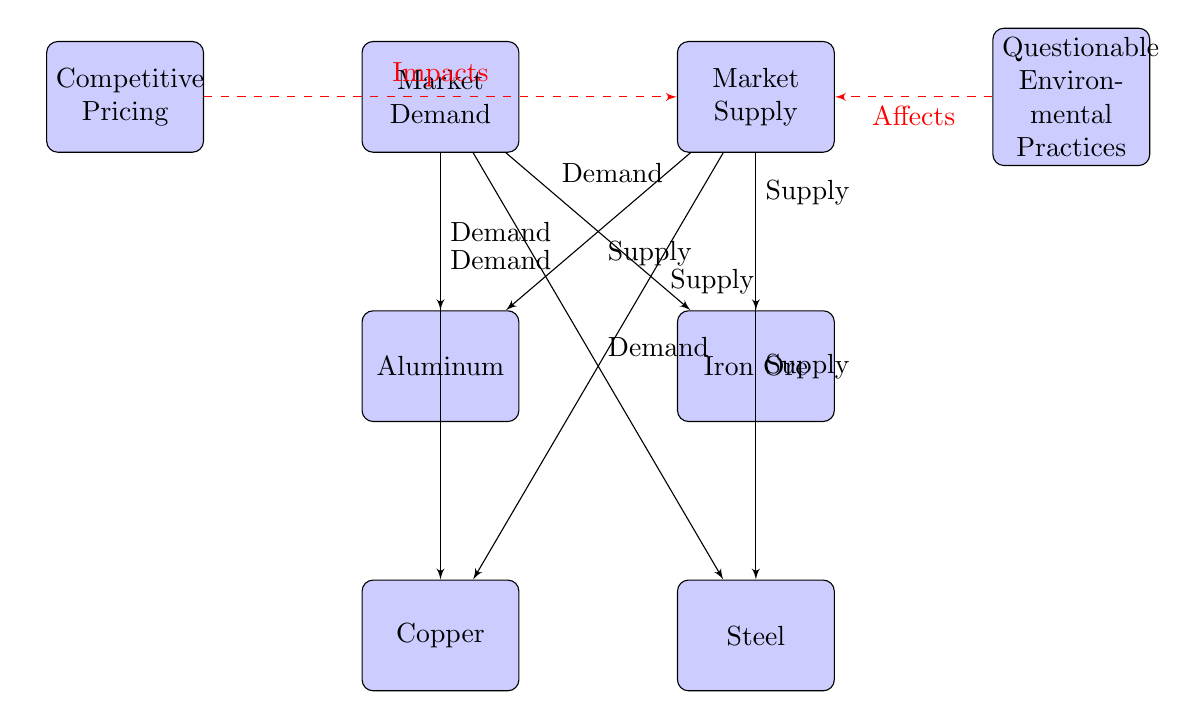What are the four raw materials depicted in the diagram? The diagram shows two blocks labeled "Aluminum," "Copper," "Iron Ore," and "Steel" arranged under the "Market Demand" and "Market Supply" nodes.
Answer: Aluminum, Copper, Iron Ore, Steel How many nodes are there in the diagram? Counting all the blocks, we have the four raw materials, two market blocks (demand and supply), and two environmental-related blocks, resulting in a total of eight nodes.
Answer: Eight What relationship is indicated between competitive pricing and supply? The diagram shows a dashed line labeled "Impacts" from the "Competitive Pricing" block to the "Market Supply" block, indicating that competitive pricing influences supply.
Answer: Impacts Which block is directly connected to both demand and supply for aluminum? The "Market Demand" block is connected to aluminum with a solid line labeled "Demand," and the "Market Supply" block is also connected to aluminum with a solid line labeled "Supply."
Answer: Aluminum What effect do questionable environmental practices have on supply? The diagram presents a dashed line labeled "Affects" from the "Questionable Environmental Practices" block pointing to the "Market Supply" block, showing that these practices have an effect on supply.
Answer: Affects How many connections does the "Market Demand" block have? The "Market Demand" block is connected to four raw materials (Aluminum, Copper, Iron Ore, Steel), giving it a total of four connections.
Answer: Four connections What is the nature of the lines connecting the "Market Demand" and "Market Supply" blocks to the raw materials? The lines connecting these blocks to the raw materials are solid, indicating a direct relationship between demand/supply and each raw material.
Answer: Solid lines Which block is positioned to the left of the "Market Demand" block? The block labeled "Competitive Pricing" is positioned directly to the left of the "Market Demand" block.
Answer: Competitive Pricing What does the diagram imply about the interaction between supply and questionable environmental practices? The dashed line labeled "Affects" from the "Questionable Environmental Practices" block to the "Market Supply" block implies that these practices negatively influence the supply of raw materials.
Answer: Affects 